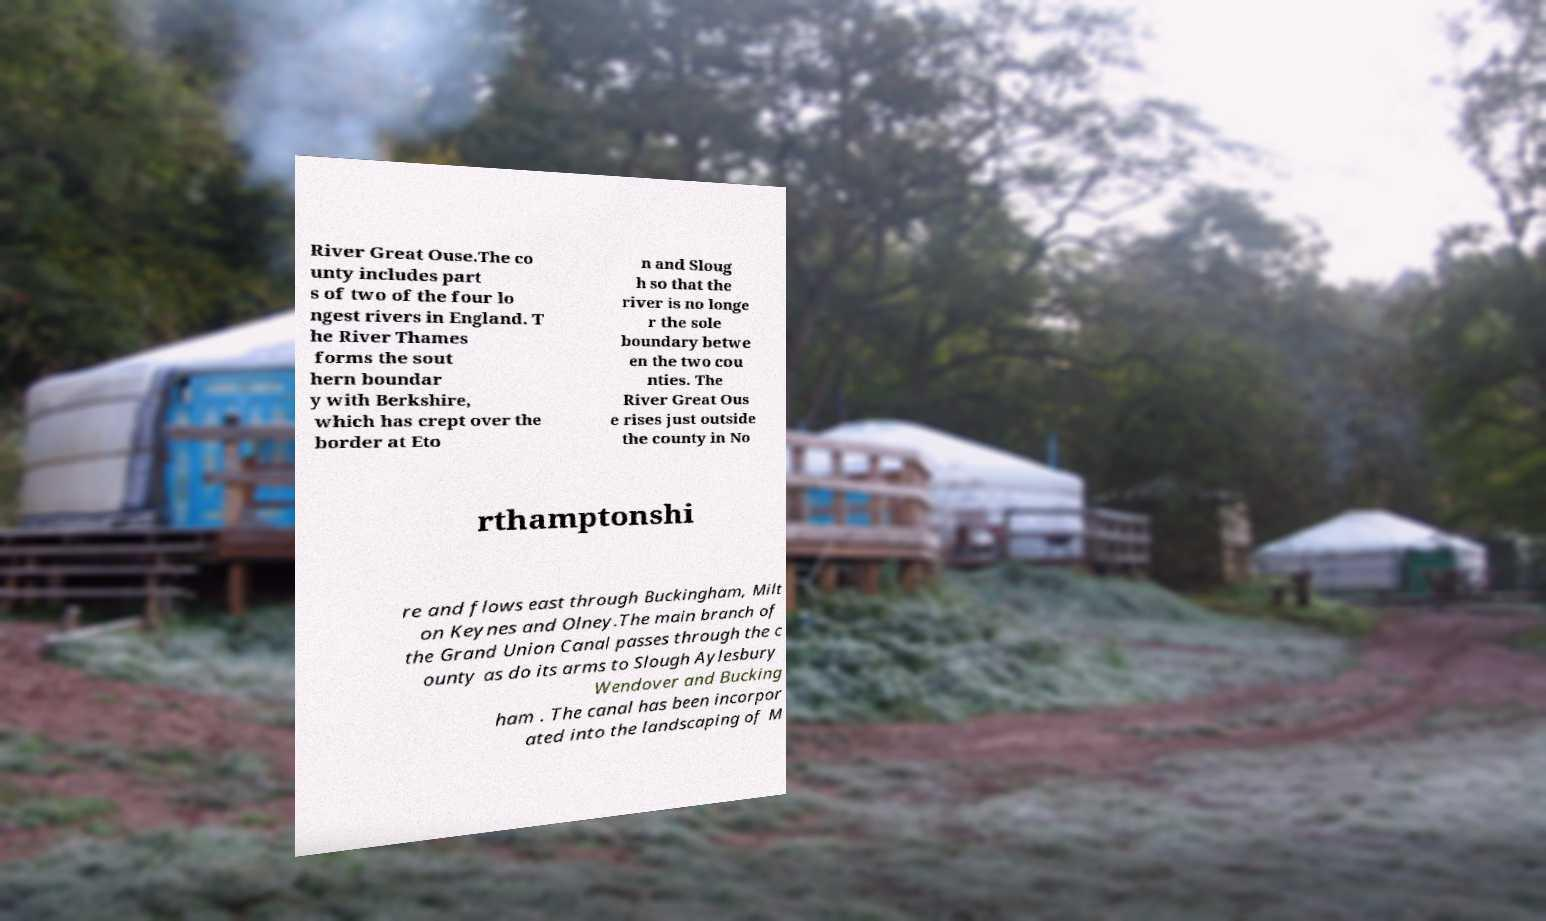I need the written content from this picture converted into text. Can you do that? River Great Ouse.The co unty includes part s of two of the four lo ngest rivers in England. T he River Thames forms the sout hern boundar y with Berkshire, which has crept over the border at Eto n and Sloug h so that the river is no longe r the sole boundary betwe en the two cou nties. The River Great Ous e rises just outside the county in No rthamptonshi re and flows east through Buckingham, Milt on Keynes and Olney.The main branch of the Grand Union Canal passes through the c ounty as do its arms to Slough Aylesbury Wendover and Bucking ham . The canal has been incorpor ated into the landscaping of M 